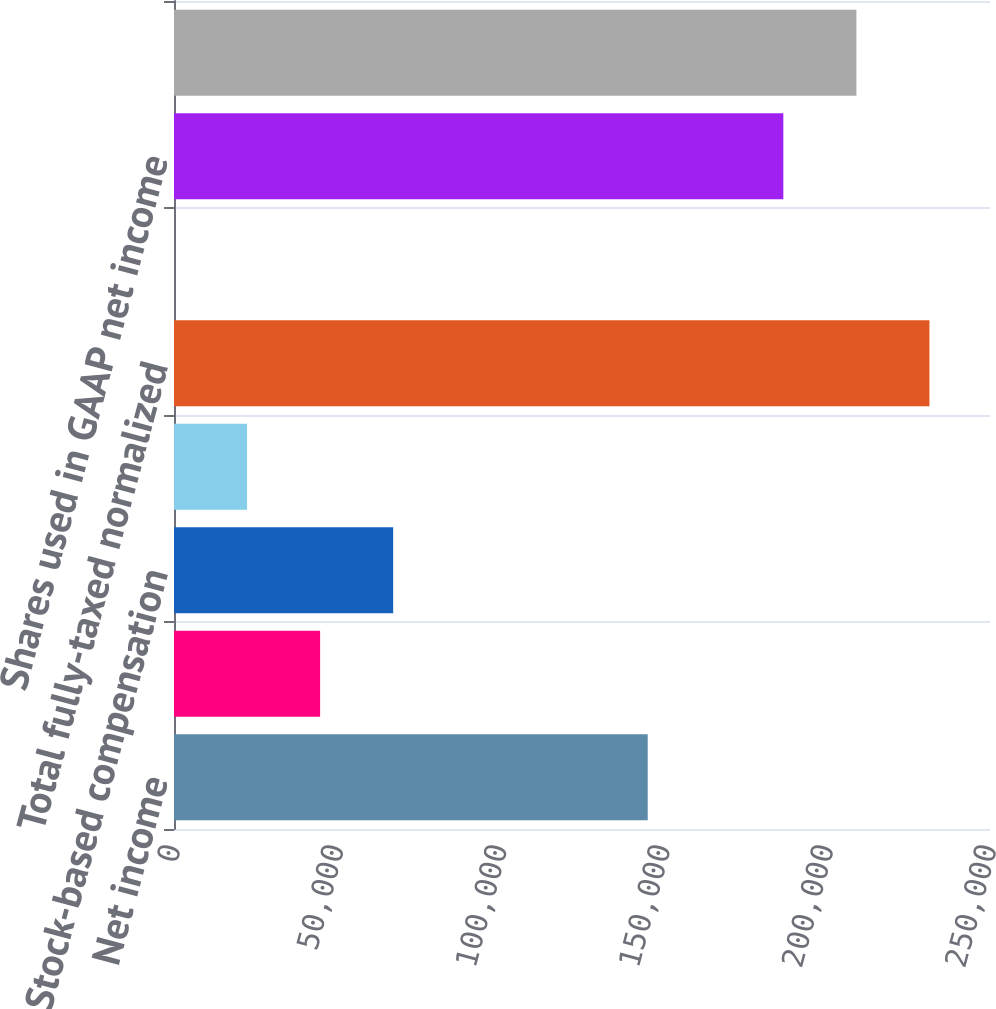<chart> <loc_0><loc_0><loc_500><loc_500><bar_chart><fcel>Net income<fcel>Amortization of other acquired<fcel>Stock-based compensation<fcel>Amortization of capitalized<fcel>Total fully-taxed normalized<fcel>Fully-taxed normalized net<fcel>Shares used in GAAP net income<fcel>Shares used in fully-taxed<nl><fcel>145138<fcel>44765<fcel>67146.8<fcel>22383.1<fcel>231449<fcel>1.2<fcel>186685<fcel>209067<nl></chart> 